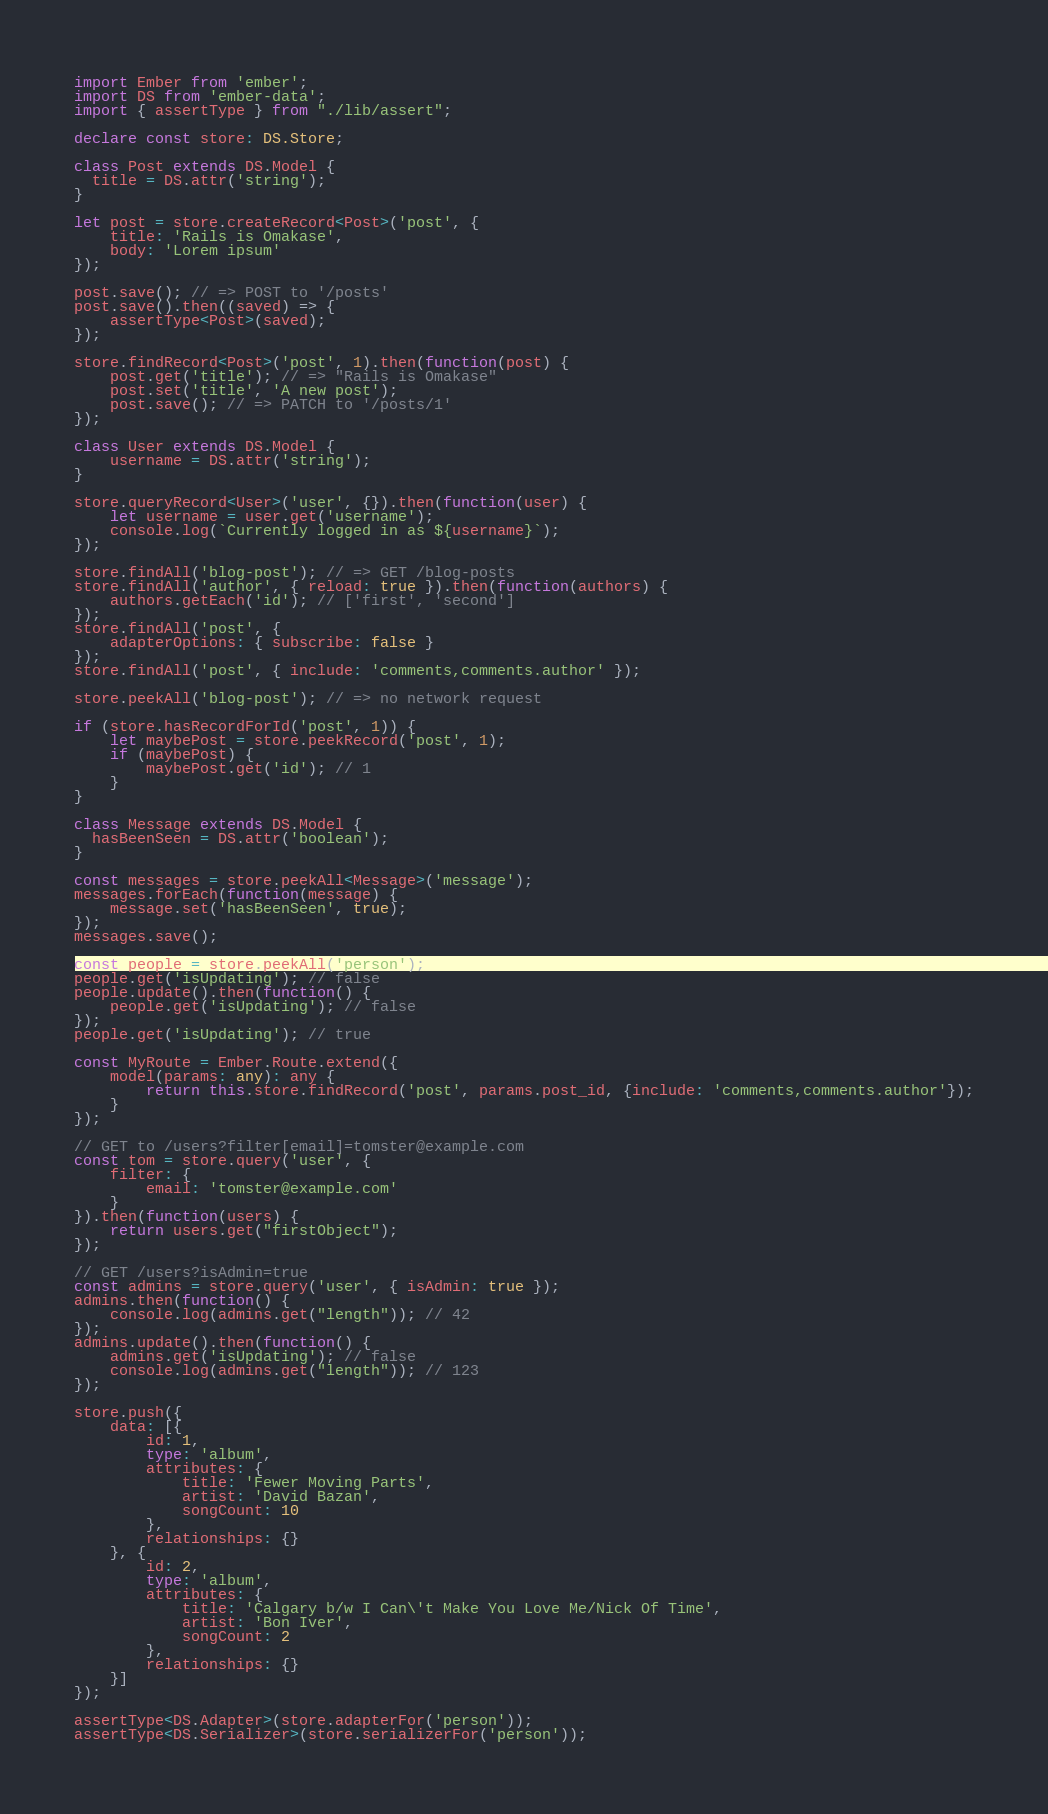Convert code to text. <code><loc_0><loc_0><loc_500><loc_500><_TypeScript_>import Ember from 'ember';
import DS from 'ember-data';
import { assertType } from "./lib/assert";

declare const store: DS.Store;

class Post extends DS.Model {
  title = DS.attr('string');
}

let post = store.createRecord<Post>('post', {
    title: 'Rails is Omakase',
    body: 'Lorem ipsum'
});

post.save(); // => POST to '/posts'
post.save().then((saved) => {
    assertType<Post>(saved);
});

store.findRecord<Post>('post', 1).then(function(post) {
    post.get('title'); // => "Rails is Omakase"
    post.set('title', 'A new post');
    post.save(); // => PATCH to '/posts/1'
});

class User extends DS.Model {
    username = DS.attr('string');
}

store.queryRecord<User>('user', {}).then(function(user) {
    let username = user.get('username');
    console.log(`Currently logged in as ${username}`);
});

store.findAll('blog-post'); // => GET /blog-posts
store.findAll('author', { reload: true }).then(function(authors) {
    authors.getEach('id'); // ['first', 'second']
});
store.findAll('post', {
    adapterOptions: { subscribe: false }
});
store.findAll('post', { include: 'comments,comments.author' });

store.peekAll('blog-post'); // => no network request

if (store.hasRecordForId('post', 1)) {
    let maybePost = store.peekRecord('post', 1);
    if (maybePost) {
        maybePost.get('id'); // 1
    }
}

class Message extends DS.Model {
  hasBeenSeen = DS.attr('boolean');
}

const messages = store.peekAll<Message>('message');
messages.forEach(function(message) {
    message.set('hasBeenSeen', true);
});
messages.save();

const people = store.peekAll('person');
people.get('isUpdating'); // false
people.update().then(function() {
    people.get('isUpdating'); // false
});
people.get('isUpdating'); // true

const MyRoute = Ember.Route.extend({
    model(params: any): any {
        return this.store.findRecord('post', params.post_id, {include: 'comments,comments.author'});
    }
});

// GET to /users?filter[email]=tomster@example.com
const tom = store.query('user', {
    filter: {
        email: 'tomster@example.com'
    }
}).then(function(users) {
    return users.get("firstObject");
});

// GET /users?isAdmin=true
const admins = store.query('user', { isAdmin: true });
admins.then(function() {
    console.log(admins.get("length")); // 42
});
admins.update().then(function() {
    admins.get('isUpdating'); // false
    console.log(admins.get("length")); // 123
});

store.push({
    data: [{
        id: 1,
        type: 'album',
        attributes: {
            title: 'Fewer Moving Parts',
            artist: 'David Bazan',
            songCount: 10
        },
        relationships: {}
    }, {
        id: 2,
        type: 'album',
        attributes: {
            title: 'Calgary b/w I Can\'t Make You Love Me/Nick Of Time',
            artist: 'Bon Iver',
            songCount: 2
        },
        relationships: {}
    }]
});

assertType<DS.Adapter>(store.adapterFor('person'));
assertType<DS.Serializer>(store.serializerFor('person'));
</code> 